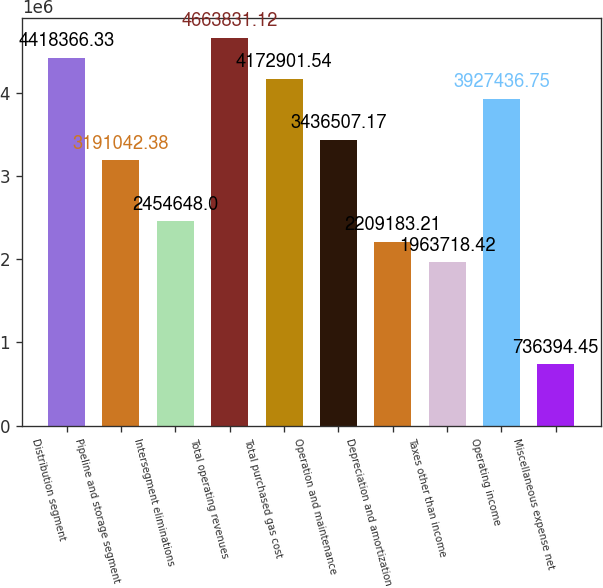Convert chart to OTSL. <chart><loc_0><loc_0><loc_500><loc_500><bar_chart><fcel>Distribution segment<fcel>Pipeline and storage segment<fcel>Intersegment eliminations<fcel>Total operating revenues<fcel>Total purchased gas cost<fcel>Operation and maintenance<fcel>Depreciation and amortization<fcel>Taxes other than income<fcel>Operating income<fcel>Miscellaneous expense net<nl><fcel>4.41837e+06<fcel>3.19104e+06<fcel>2.45465e+06<fcel>4.66383e+06<fcel>4.1729e+06<fcel>3.43651e+06<fcel>2.20918e+06<fcel>1.96372e+06<fcel>3.92744e+06<fcel>736394<nl></chart> 